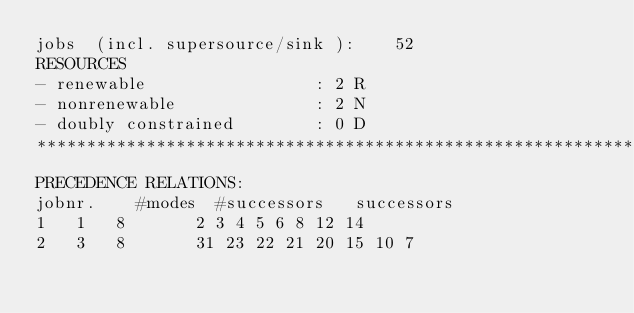Convert code to text. <code><loc_0><loc_0><loc_500><loc_500><_ObjectiveC_>jobs  (incl. supersource/sink ):	52
RESOURCES
- renewable                 : 2 R
- nonrenewable              : 2 N
- doubly constrained        : 0 D
************************************************************************
PRECEDENCE RELATIONS:
jobnr.    #modes  #successors   successors
1	1	8		2 3 4 5 6 8 12 14 
2	3	8		31 23 22 21 20 15 10 7 </code> 